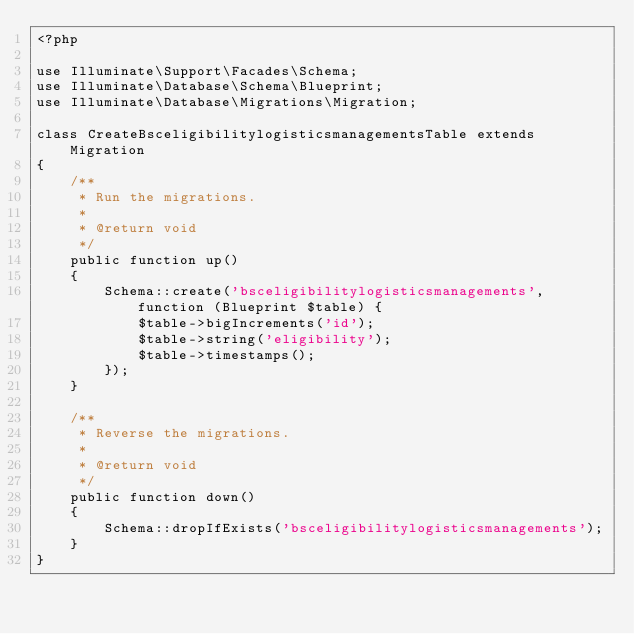<code> <loc_0><loc_0><loc_500><loc_500><_PHP_><?php

use Illuminate\Support\Facades\Schema;
use Illuminate\Database\Schema\Blueprint;
use Illuminate\Database\Migrations\Migration;

class CreateBsceligibilitylogisticsmanagementsTable extends Migration
{
    /**
     * Run the migrations.
     *
     * @return void
     */
    public function up()
    {
        Schema::create('bsceligibilitylogisticsmanagements', function (Blueprint $table) {
            $table->bigIncrements('id');
            $table->string('eligibility');
            $table->timestamps();
        });
    }

    /**
     * Reverse the migrations.
     *
     * @return void
     */
    public function down()
    {
        Schema::dropIfExists('bsceligibilitylogisticsmanagements');
    }
}
</code> 